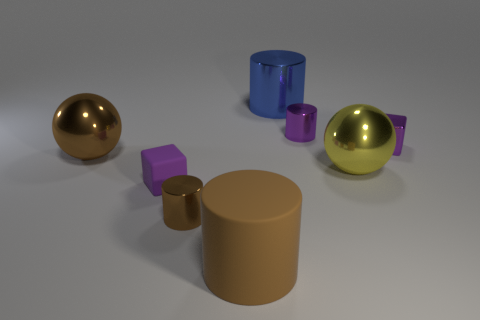There is a ball that is the same color as the matte cylinder; what size is it?
Offer a terse response. Large. There is a tiny matte thing that is the same color as the metal cube; what is its shape?
Your answer should be very brief. Cube. What number of other things are there of the same material as the yellow sphere
Provide a short and direct response. 5. There is a blue metal thing; does it have the same size as the shiny thing that is on the left side of the tiny brown cylinder?
Your answer should be compact. Yes. Are there fewer brown cylinders right of the large yellow metal sphere than yellow metallic things?
Ensure brevity in your answer.  Yes. There is another brown object that is the same shape as the tiny brown thing; what is its material?
Offer a terse response. Rubber. What is the shape of the big metal object that is both in front of the purple shiny cylinder and left of the purple cylinder?
Your answer should be very brief. Sphere. There is a small brown thing that is made of the same material as the yellow ball; what shape is it?
Your answer should be compact. Cylinder. There is a large ball left of the blue metallic thing; what is it made of?
Your response must be concise. Metal. There is a purple cube left of the brown matte cylinder; is it the same size as the sphere that is right of the large brown sphere?
Your answer should be very brief. No. 